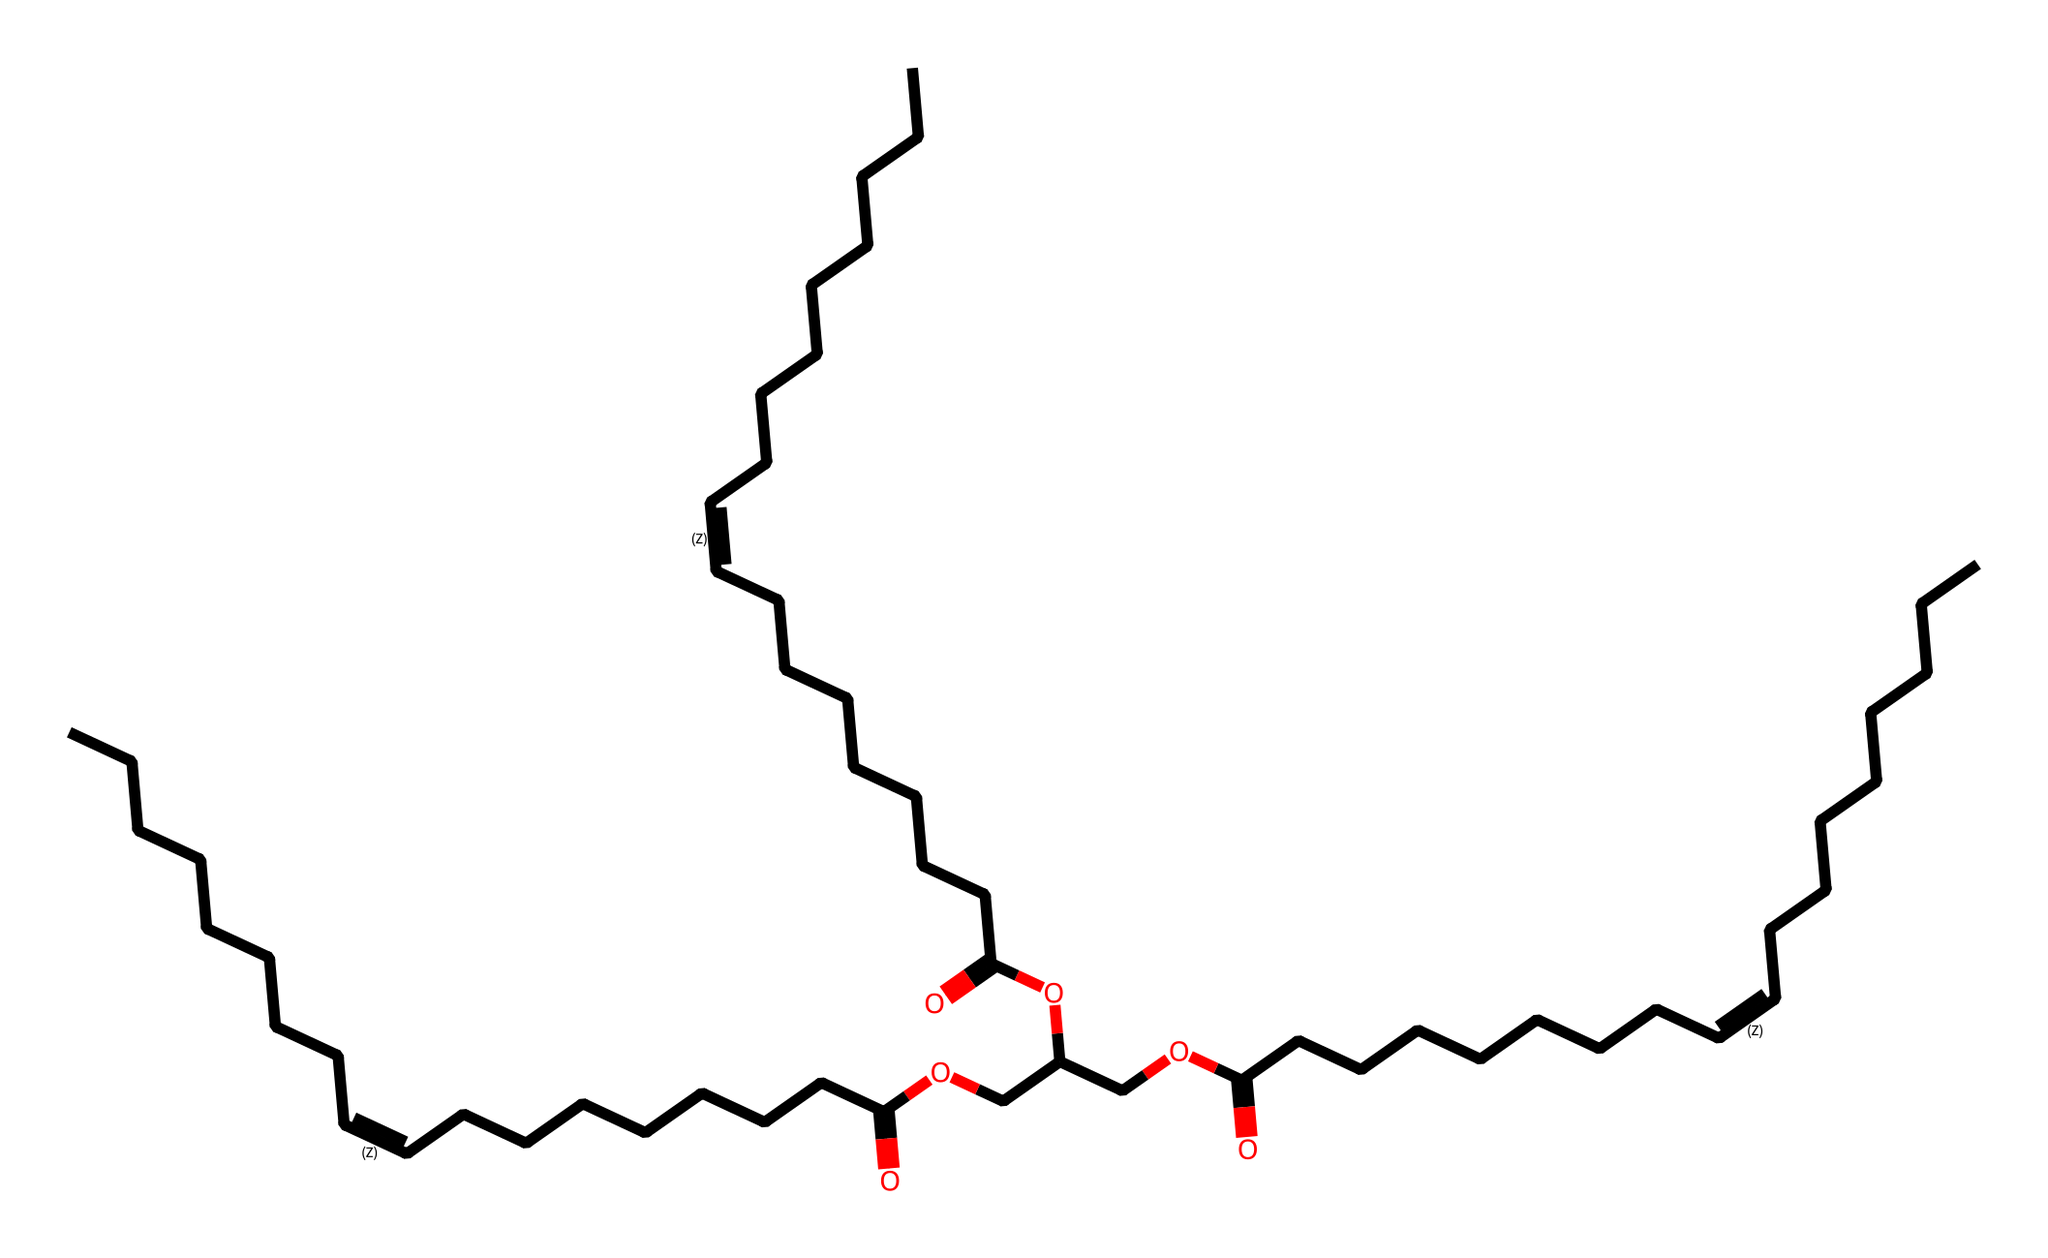what is the total number of carbon atoms in this molecule? By analyzing the SMILES representation, we count the number of 'C' characters that represent carbon atoms. There are 36 carbon atoms indicated throughout the structure.
Answer: 36 how many double bonds are present in this molecule? The structure contains double bond indicators represented by '/=' symbols in the SMILES. Counting these symbols in the representation shows that there are 6 instances of the double bond.
Answer: 6 what functional group is indicated by the 'O' attached to 'C(=O)'? The 'C(=O)' structure represents a carbonyl functional group, where the oxygen is double-bonded to the carbon, indicating that this molecule contains carboxylic acids due to the hydroxyl '-OH' group also shown connected to 'C(=O)'.
Answer: carboxylic acid is this molecule saturated or unsaturated? The presence of double bonds (as evidenced by the '/=') in the structure indicates that the molecule contains unsaturated carbon chains, thus classifying it as unsaturated.
Answer: unsaturated what type of hydrocarbons is this compound classified as? The presence of both aliphatic chains (with straight-chain hydrocarbons) and the inclusion of double bonds means that the compound fits the classification of unsaturated fats within the hydrocarbon family.
Answer: unsaturated fats 